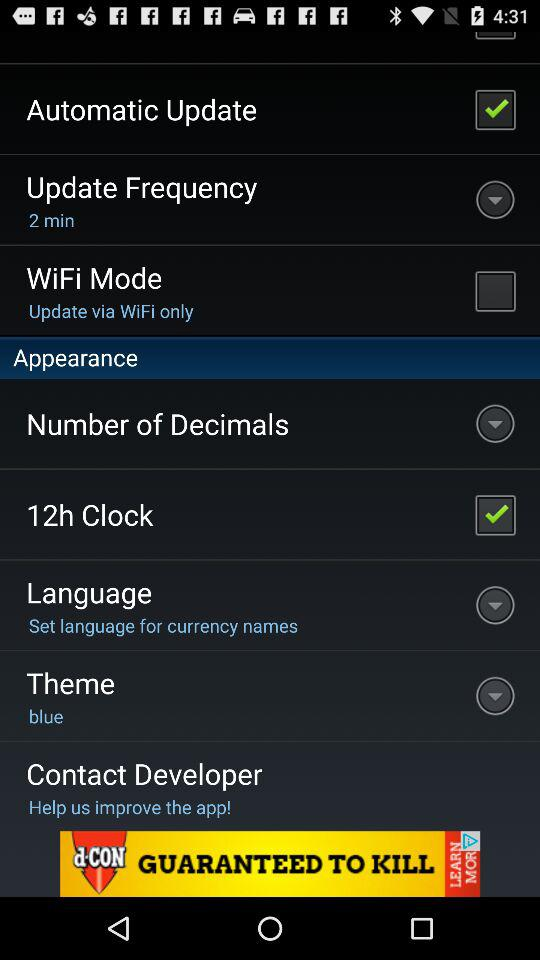What is the status of "Automatic Update"? The status is "on". 